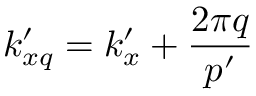Convert formula to latex. <formula><loc_0><loc_0><loc_500><loc_500>k _ { x q } ^ { \prime } = k _ { x } ^ { \prime } + \frac { 2 \pi q } { p ^ { \prime } }</formula> 